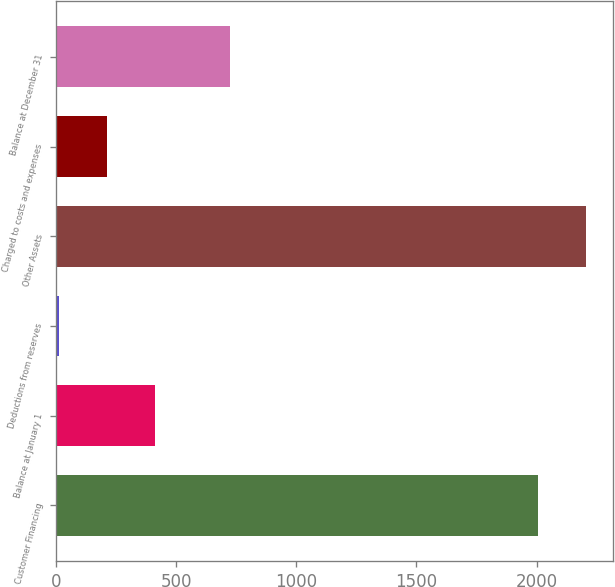Convert chart. <chart><loc_0><loc_0><loc_500><loc_500><bar_chart><fcel>Customer Financing<fcel>Balance at January 1<fcel>Deductions from reserves<fcel>Other Assets<fcel>Charged to costs and expenses<fcel>Balance at December 31<nl><fcel>2008<fcel>409.6<fcel>10<fcel>2207.8<fcel>209.8<fcel>723<nl></chart> 